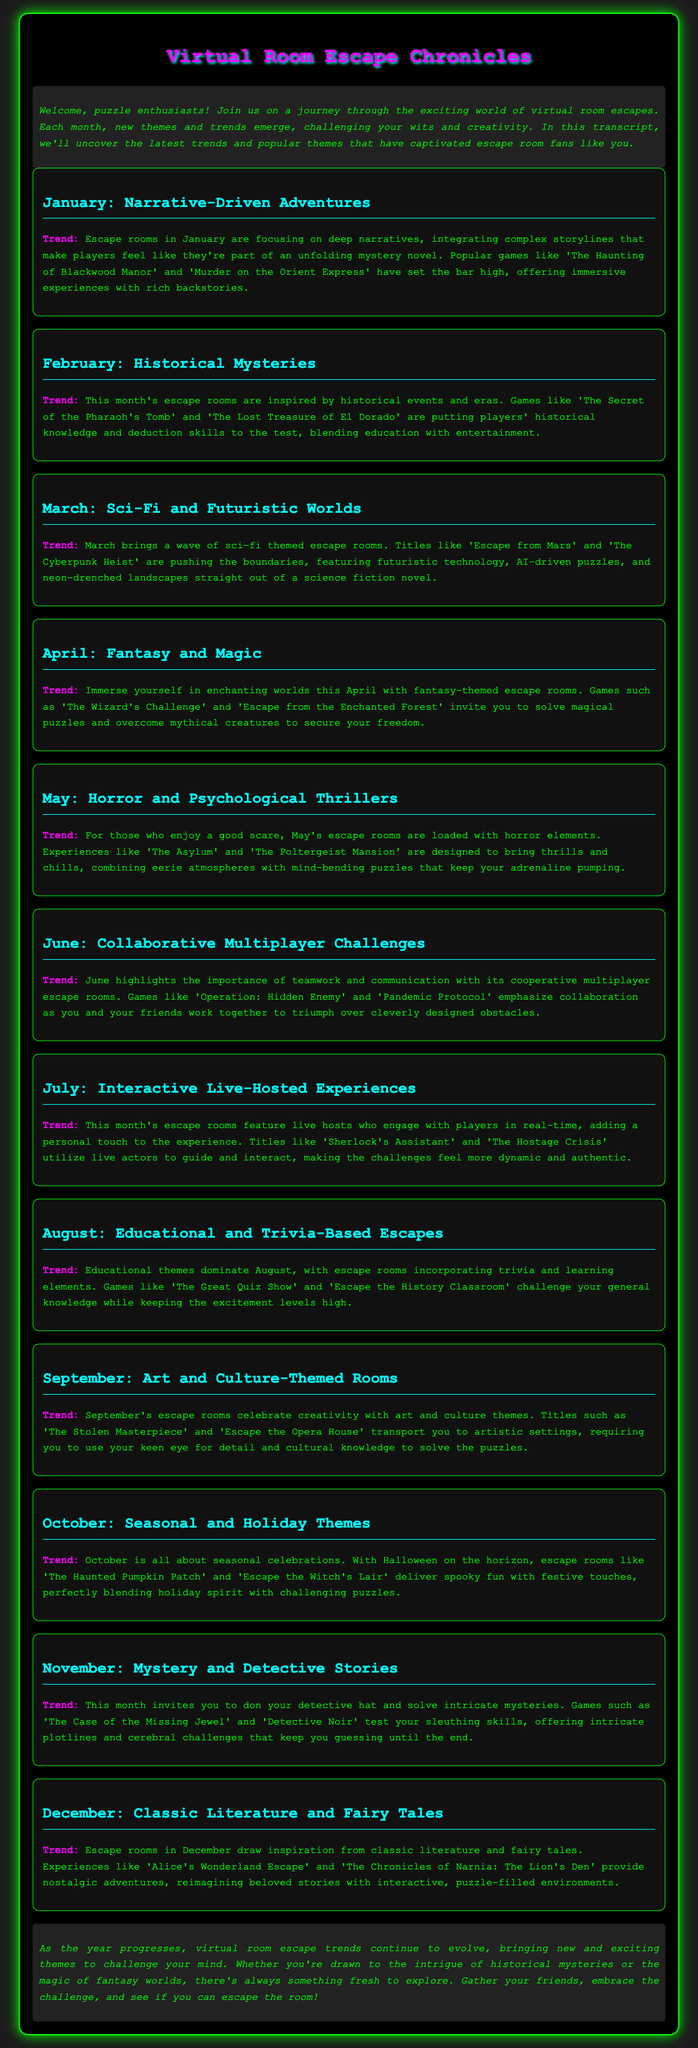what is the theme of January? January features escape rooms focusing on deep narratives and complex storylines.
Answer: Narrative-Driven Adventures which game is mentioned for February? The game 'The Secret of the Pharaoh's Tomb' is cited as a popular escape room for February.
Answer: The Secret of the Pharaoh's Tomb what are the main elements of May's escape rooms? May's escape rooms are designed with horror elements and psychological thriller aspects.
Answer: Horror and Psychological Thrillers how many months are dedicated to educational themes? There is one month, August, dedicated to educational themes.
Answer: One which month features interactive live-hosted experiences? July features escape rooms with live hosts engaging with players.
Answer: July name a game from the sci-fi category. 'Escape from Mars' is mentioned as a title under the sci-fi theme for March.
Answer: Escape from Mars what type of experiences are highlighted in June? June highlights cooperative multiplayer escape rooms emphasizing teamwork.
Answer: Collaborative Multiplayer Challenges what kind of adventures does December offer? December offers escape rooms inspired by classic literature and fairy tales.
Answer: Classic Literature and Fairy Tales which trend is significant in October's escape rooms? October escape rooms are themed around seasonal celebrations and Halloween.
Answer: Seasonal and Holiday Themes 